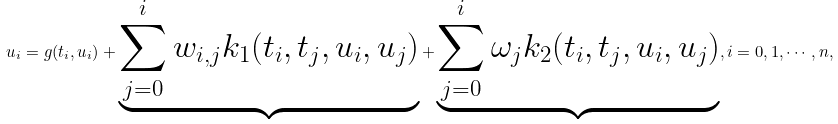<formula> <loc_0><loc_0><loc_500><loc_500>u _ { i } = g ( t _ { i } , u _ { i } ) + \underbrace { \sum _ { j = 0 } ^ { i } w _ { i , j } k _ { 1 } ( t _ { i } , t _ { j } , { u } _ { i } , { u } _ { j } ) } + \underbrace { \sum _ { j = 0 } ^ { i } \omega _ { j } k _ { 2 } ( t _ { i } , t _ { j } , { u } _ { i } , { u } _ { j } ) } , i = 0 , 1 , \cdots , n ,</formula> 